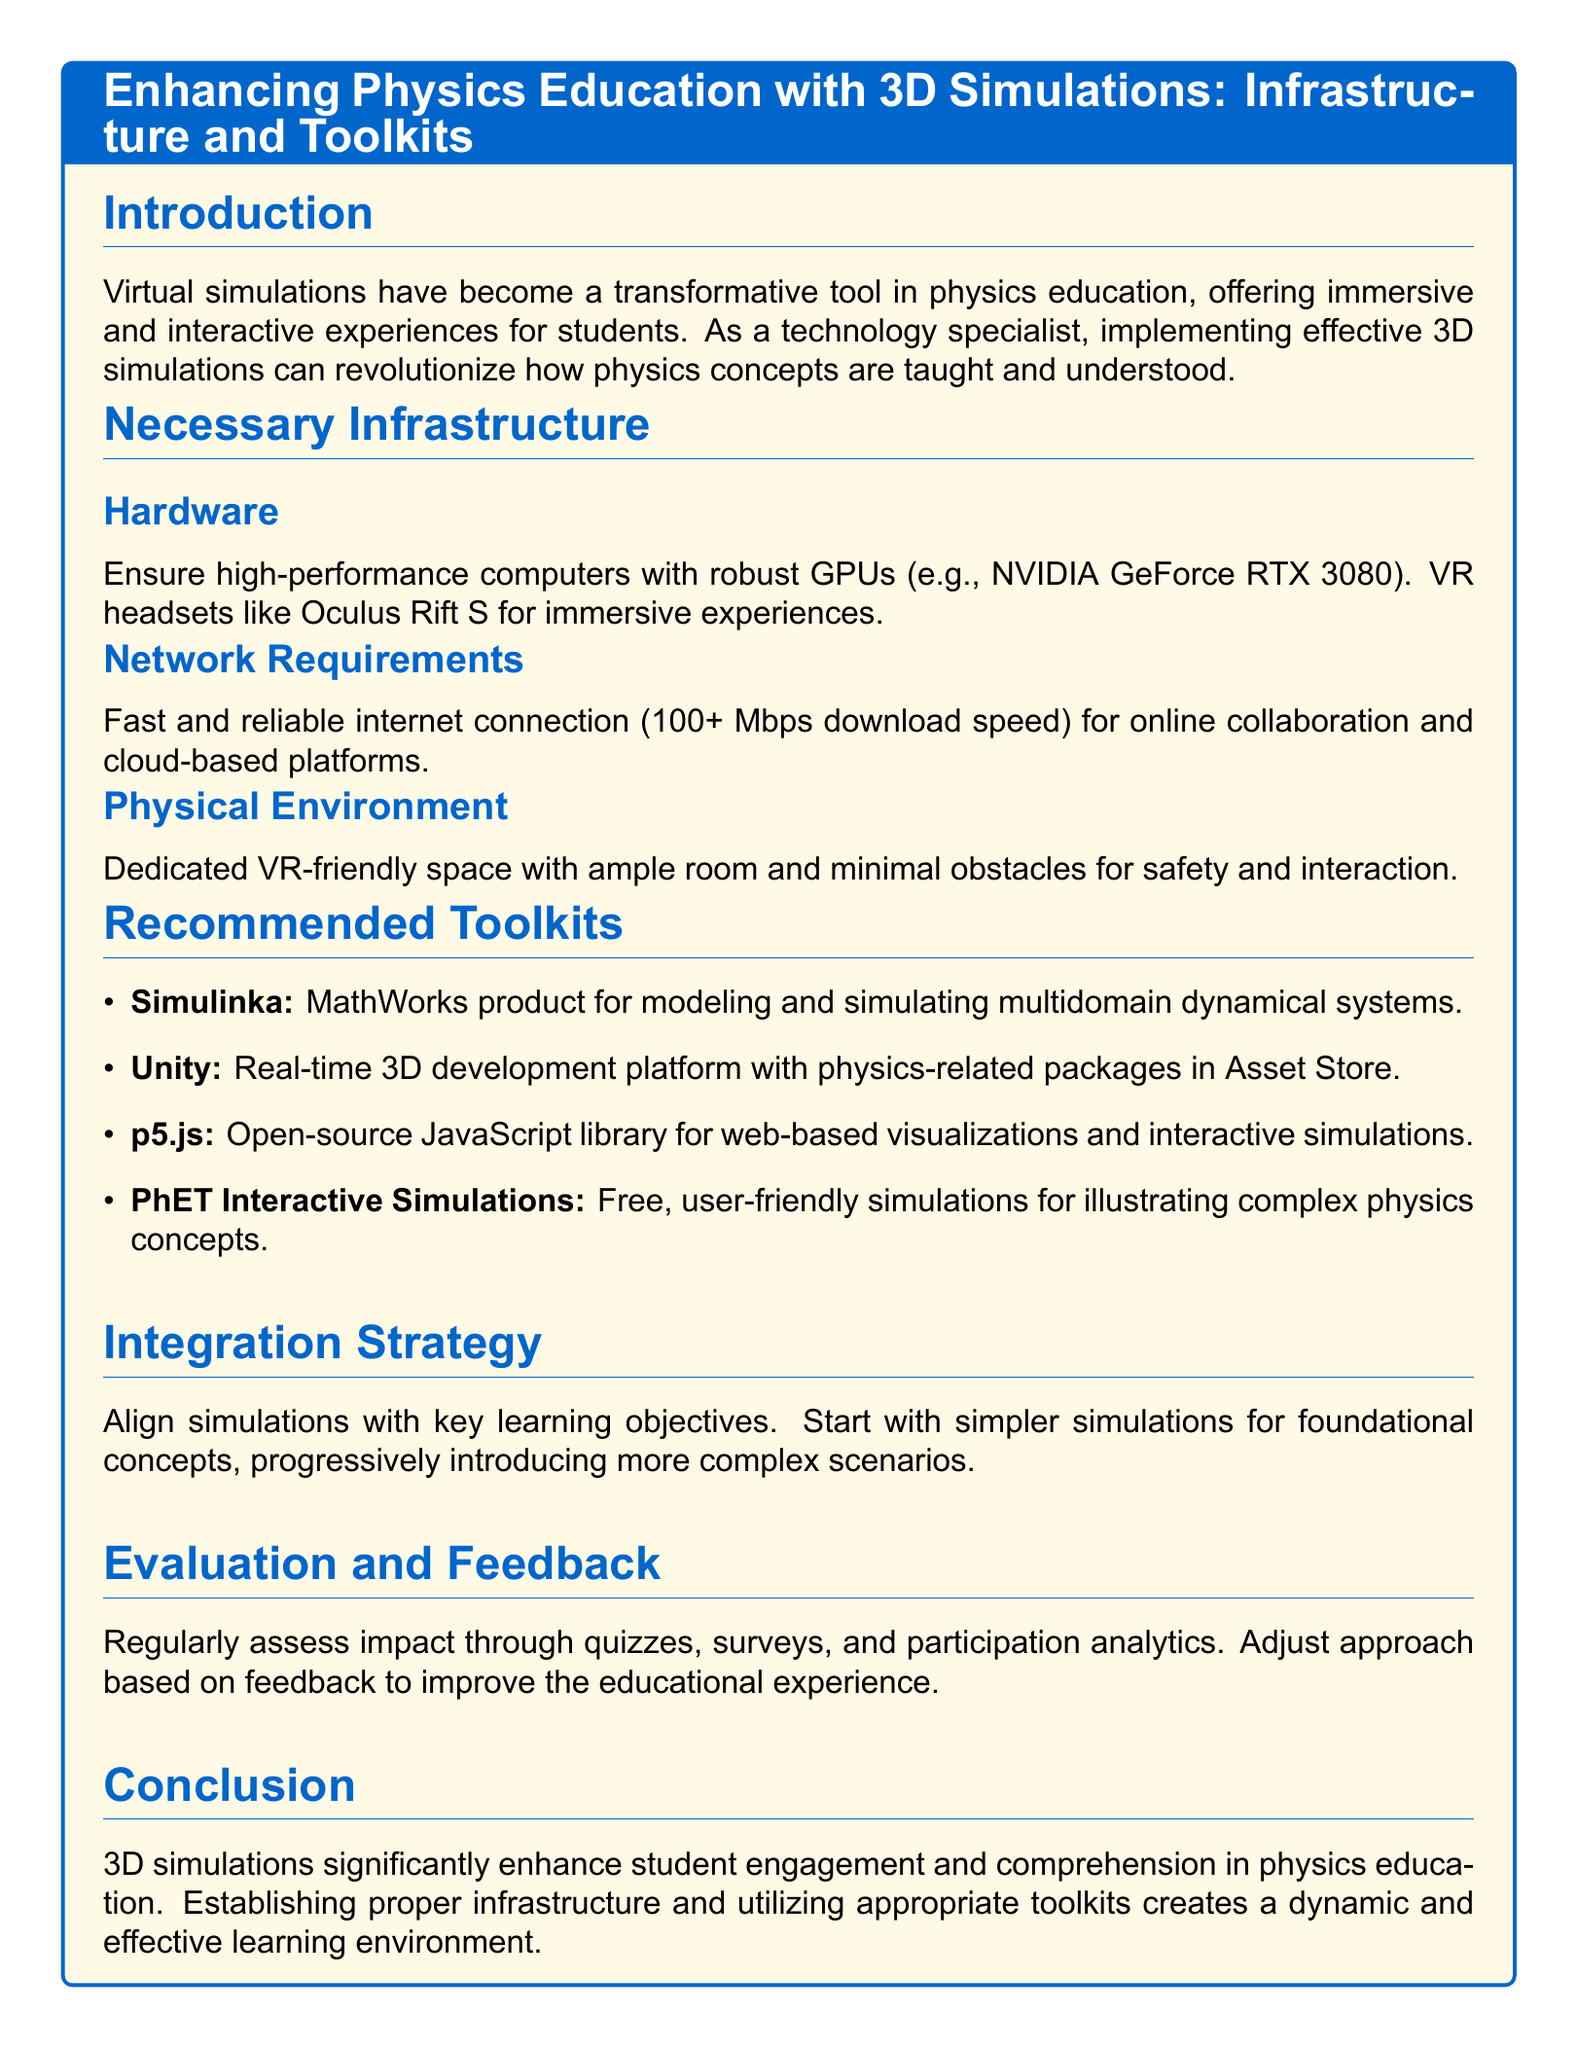what is the main topic of the document? The main topic focuses on how to enhance physics education using 3D simulations.
Answer: Enhancing Physics Education with 3D Simulations what is required for the hardware? The document specifies high-performance computers with robust GPUs like NVIDIA GeForce RTX 3080.
Answer: NVIDIA GeForce RTX 3080 what is a recommended software toolkit for web-based visualizations? The document lists p5.js as an open-source JavaScript library for visualizations.
Answer: p5.js what internet speed is recommended for effective simulation implementation? A fast and reliable internet connection of 100+ Mbps download speed is required.
Answer: 100+ Mbps which VR headset is suggested for immersive experiences? Oculus Rift S is recommended for immersive experiences in the document.
Answer: Oculus Rift S what should be aligned with key learning objectives? Simulations should be aligned with key learning objectives in the educational process.
Answer: Simulations how should simulations be introduced according to the integration strategy? Begin with simpler simulations for foundational concepts before introducing more complex scenarios.
Answer: Simpler simulations what assessment methods are suggested for evaluating the impact of simulations? The document suggests quizzes, surveys, and participation analytics for assessment.
Answer: Quizzes, surveys, and participation analytics what is the conclusion regarding 3D simulations in physics education? The conclusion states that 3D simulations enhance student engagement and comprehension.
Answer: Enhance student engagement and comprehension 